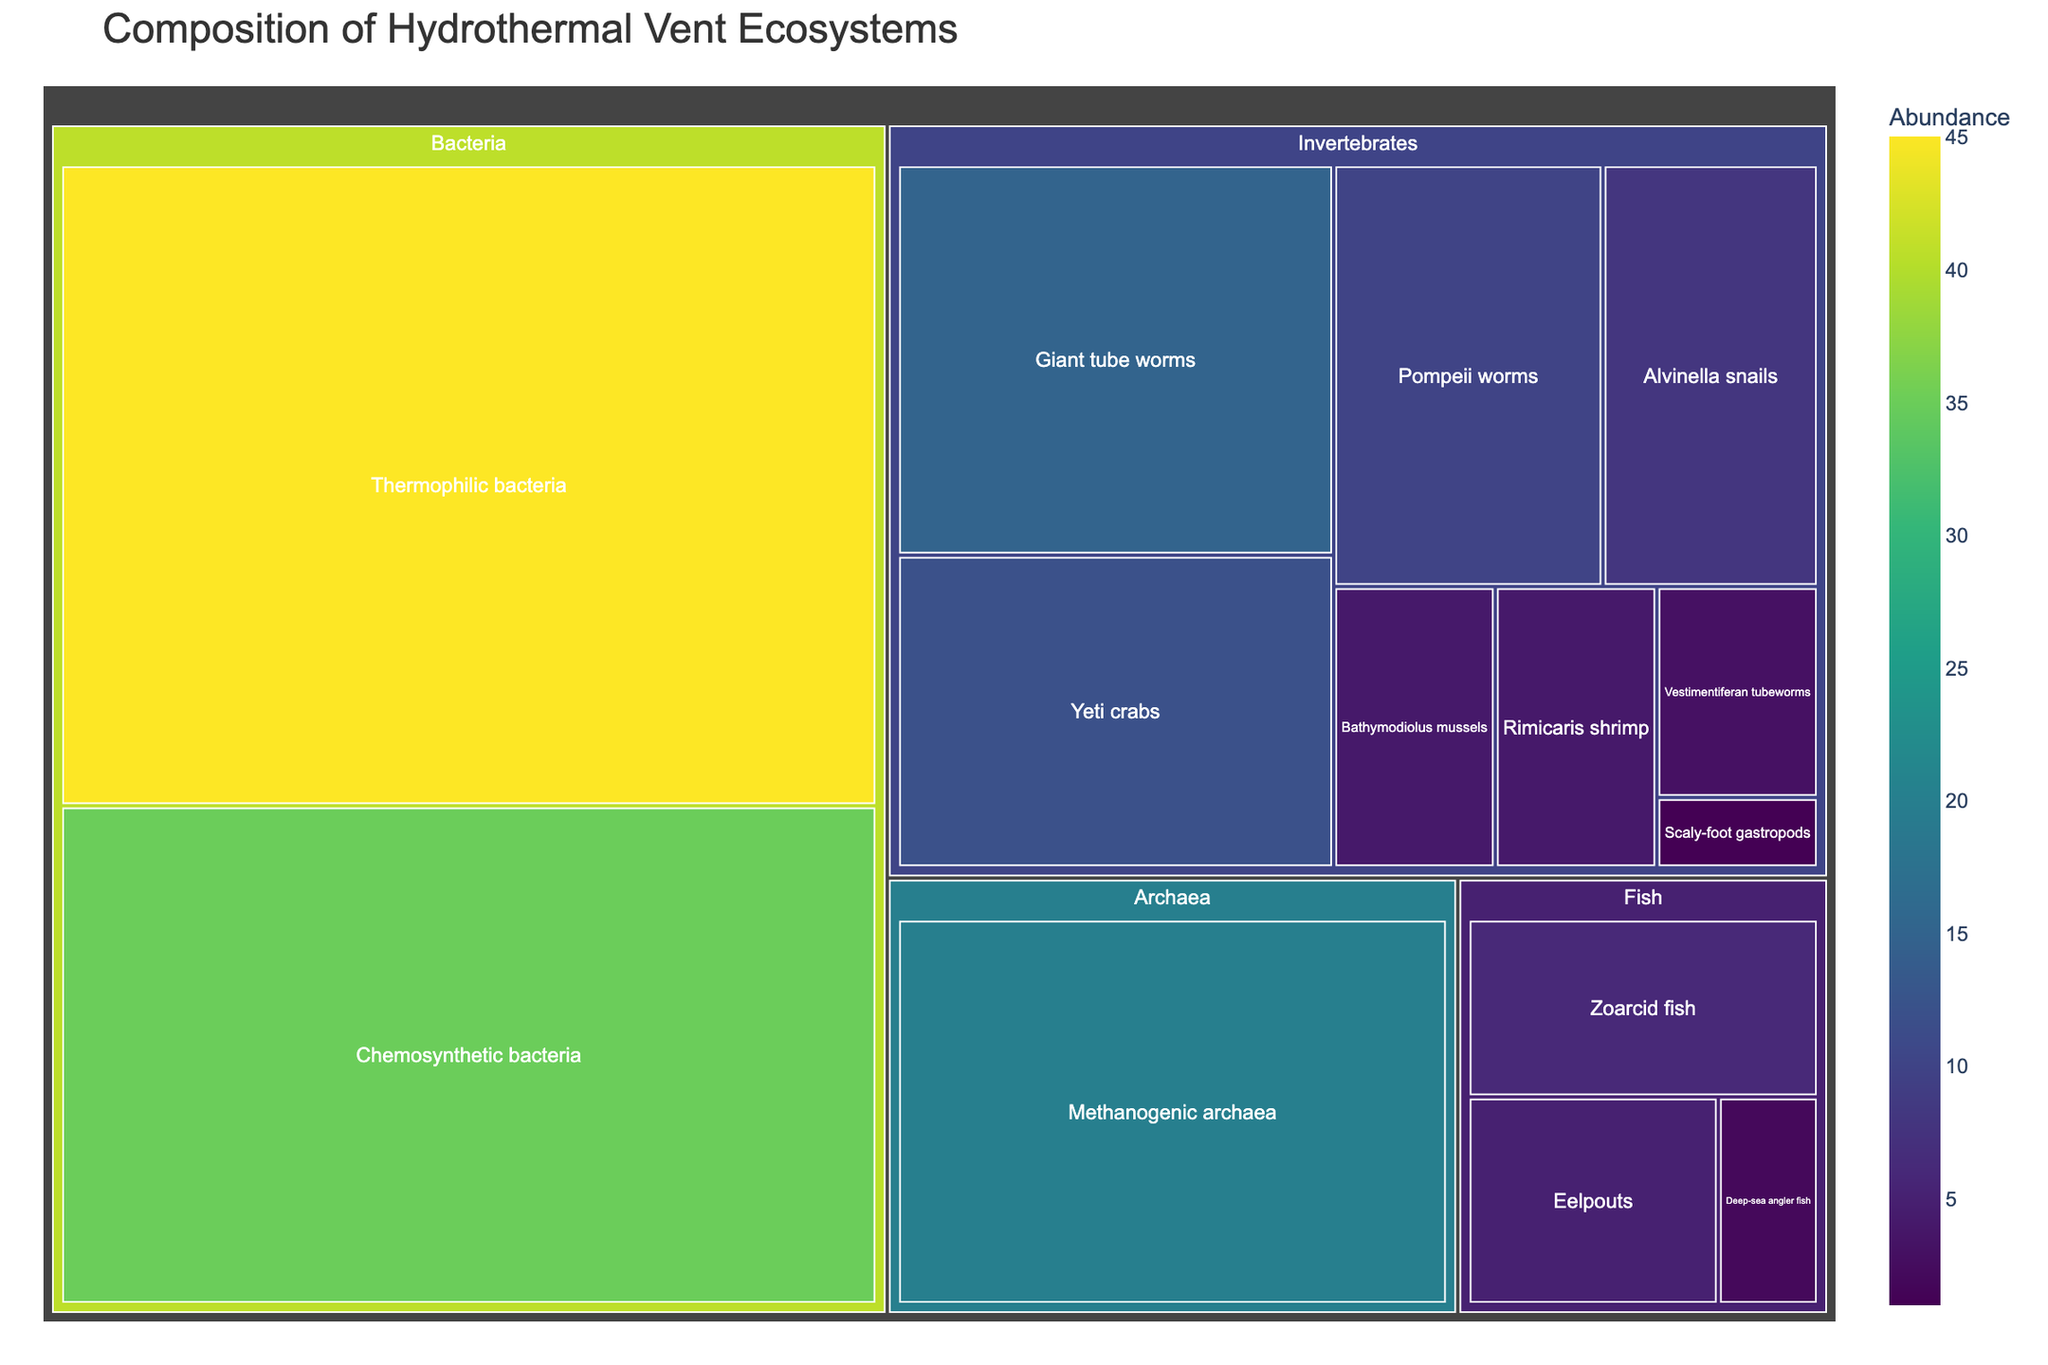what's the title of the plot? The title is directly displayed at the top of the treemap.
Answer: Composition of Hydrothermal Vent Ecosystems which organism has the highest abundance? The largest section of the treemap represents the organism with the highest abundance.
Answer: Thermophilic bacteria which category has the most diverse types of organisms? By counting the number of different organisms in each category, we find that the Invertebrates category has the most diversity.
Answer: Invertebrates what is the sum of the abundance of all bacteria types? Add the abundances of Thermophilic bacteria (45) and Chemosynthetic bacteria (35). 45 + 35 = 80
Answer: 80 are there more fish or archaea in the ecosystem? Compare the sum of the abundances of Fish (6 + 5 + 2 = 13) with that of Archaea (20).
Answer: Archaea which is the least abundant organism? The smallest section of the treemap corresponds to the organism with the least abundance.
Answer: Scaly-foot gastropods what is the combined abundance of all invertebrates? Sum the abundances of all organisms in the Invertebrates category: 15 + 12 + 10 + 8 + 4 + 4 + 3 + 1 = 57
Answer: 57 how does the abundance of giant tube worms compare to yeti crabs? Compare the numbers: Giant tube worms (15) are more abundant than yeti crabs (12).
Answer: Giant tube worms are more abundant what percentage of the total abundance do chemosynthetic bacteria represent? Calculate the total abundance of all organisms (159). Then, (35 / 159) * 100 gives approximately 22.01%.
Answer: ~22.01% which fish has the lowest abundance? The smallest fish section in the treemap corresponds to Deep-sea angler fish with an abundance of 2.
Answer: Deep-sea angler fish 